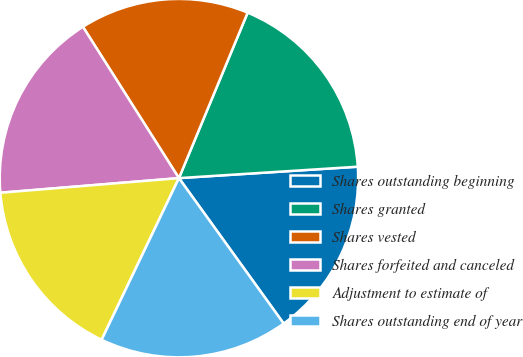Convert chart. <chart><loc_0><loc_0><loc_500><loc_500><pie_chart><fcel>Shares outstanding beginning<fcel>Shares granted<fcel>Shares vested<fcel>Shares forfeited and canceled<fcel>Adjustment to estimate of<fcel>Shares outstanding end of year<nl><fcel>16.08%<fcel>17.72%<fcel>15.26%<fcel>17.3%<fcel>16.6%<fcel>17.03%<nl></chart> 